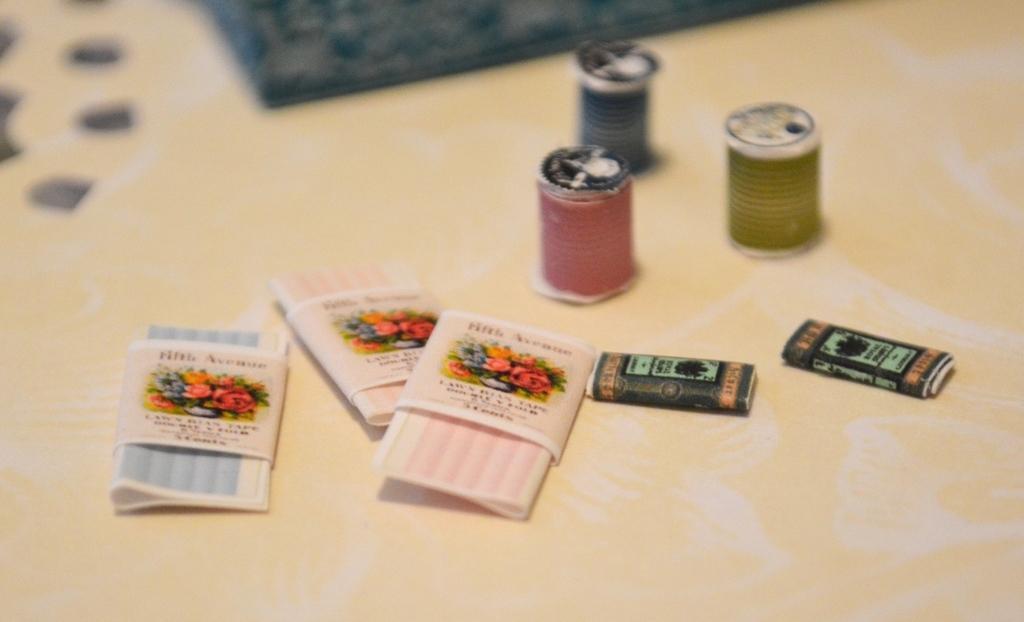How would you summarize this image in a sentence or two? In this image I can see few objects on the cream color surface and the objects are in red, green, black and pink color. 